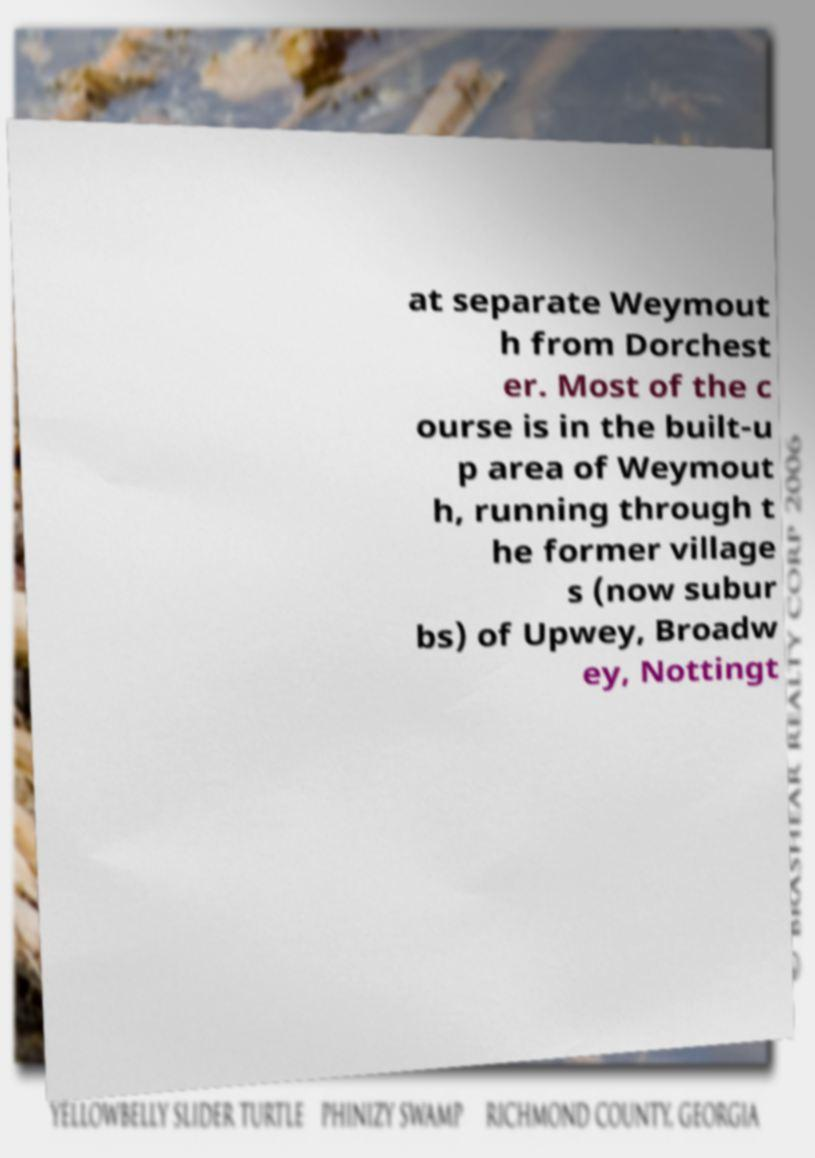I need the written content from this picture converted into text. Can you do that? at separate Weymout h from Dorchest er. Most of the c ourse is in the built-u p area of Weymout h, running through t he former village s (now subur bs) of Upwey, Broadw ey, Nottingt 